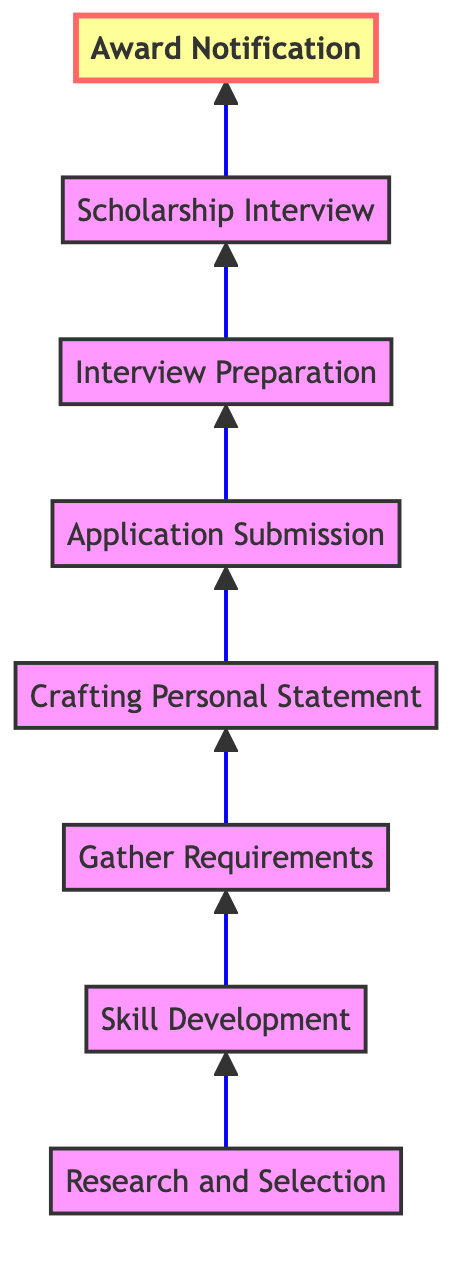What is the first step in the flow? The first step in the flow chart is described as "Research and Selection", which is indicated at the bottom of the diagram as the starting point.
Answer: Research and Selection How many steps are there in total? The flow chart contains eight steps, which can be counted from the bottom to the top.
Answer: 8 What follows "Gather Requirements"? The step that follows "Gather Requirements" in the flow chart is "Crafting Personal Statement", which is the next node connected upward.
Answer: Crafting Personal Statement What is the last step before the scholarship is awarded? The last step before receiving the scholarship award is "Scholarship Interview", which is indicated just above "Interview Preparation" in the diagram.
Answer: Scholarship Interview Which step involves documenting your achievements? The step involving documenting achievements is "Gather Requirements", as it includes collecting necessary documents such as transcripts and certificates.
Answer: Gather Requirements What type of questions should be practiced in the "Interview Preparation" step? The "Interview Preparation" step focuses on practicing common questions, which means one must prepare for potential scholarship interview queries related to their sports and academic journey.
Answer: Common questions Is "Award Notification" the final step in the process? Yes, "Award Notification" is indeed the final step in the flow chart, positioned at the top, indicating the completion of the scholarship application process.
Answer: Yes How many steps precede the "Application Submission"? There are four steps that precede "Application Submission": "Research and Selection", "Skill Development", "Gather Requirements", and "Crafting Personal Statement".
Answer: 4 What step focuses on training and competitions? The step that focuses on training and competitions is "Skill Development", which emphasizes enhancing athletic skills through rigorous training and participation in competitions.
Answer: Skill Development 